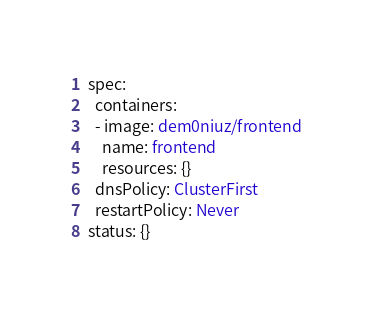<code> <loc_0><loc_0><loc_500><loc_500><_YAML_>spec:
  containers:
  - image: dem0niuz/frontend
    name: frontend
    resources: {}
  dnsPolicy: ClusterFirst
  restartPolicy: Never
status: {}
</code> 